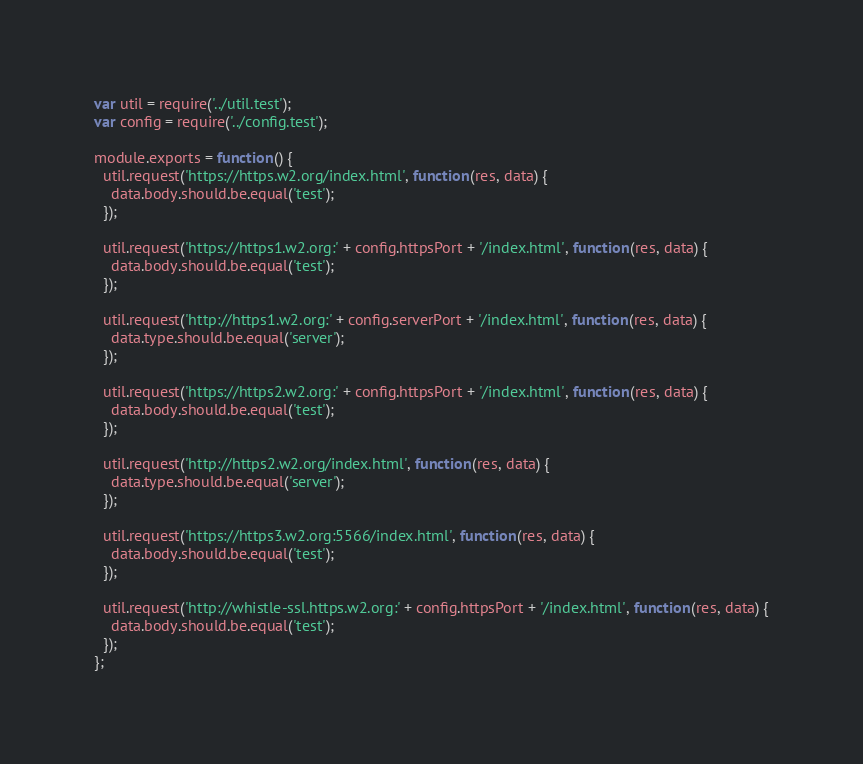Convert code to text. <code><loc_0><loc_0><loc_500><loc_500><_JavaScript_>var util = require('../util.test');
var config = require('../config.test');

module.exports = function() {
  util.request('https://https.w2.org/index.html', function(res, data) {
    data.body.should.be.equal('test');
  });
  
  util.request('https://https1.w2.org:' + config.httpsPort + '/index.html', function(res, data) {
    data.body.should.be.equal('test');
  });
  
  util.request('http://https1.w2.org:' + config.serverPort + '/index.html', function(res, data) {
    data.type.should.be.equal('server');
  });
  
  util.request('https://https2.w2.org:' + config.httpsPort + '/index.html', function(res, data) {
    data.body.should.be.equal('test');
  });
  
  util.request('http://https2.w2.org/index.html', function(res, data) {
    data.type.should.be.equal('server');
  });
  
  util.request('https://https3.w2.org:5566/index.html', function(res, data) {
    data.body.should.be.equal('test');
  });
  
  util.request('http://whistle-ssl.https.w2.org:' + config.httpsPort + '/index.html', function(res, data) {
    data.body.should.be.equal('test');
  });
};
</code> 